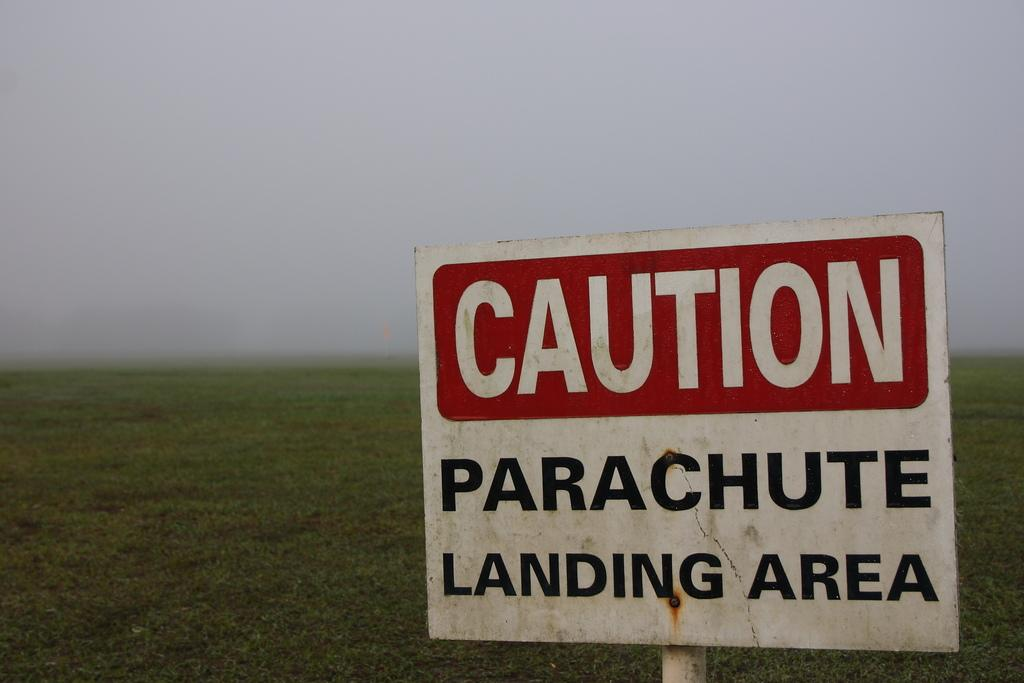<image>
Present a compact description of the photo's key features. A caution sign says that parachutes land here. 